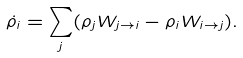Convert formula to latex. <formula><loc_0><loc_0><loc_500><loc_500>\dot { \rho } _ { i } = \sum _ { j } ( \rho _ { j } W _ { j \to i } - \rho _ { i } W _ { i \to j } ) .</formula> 